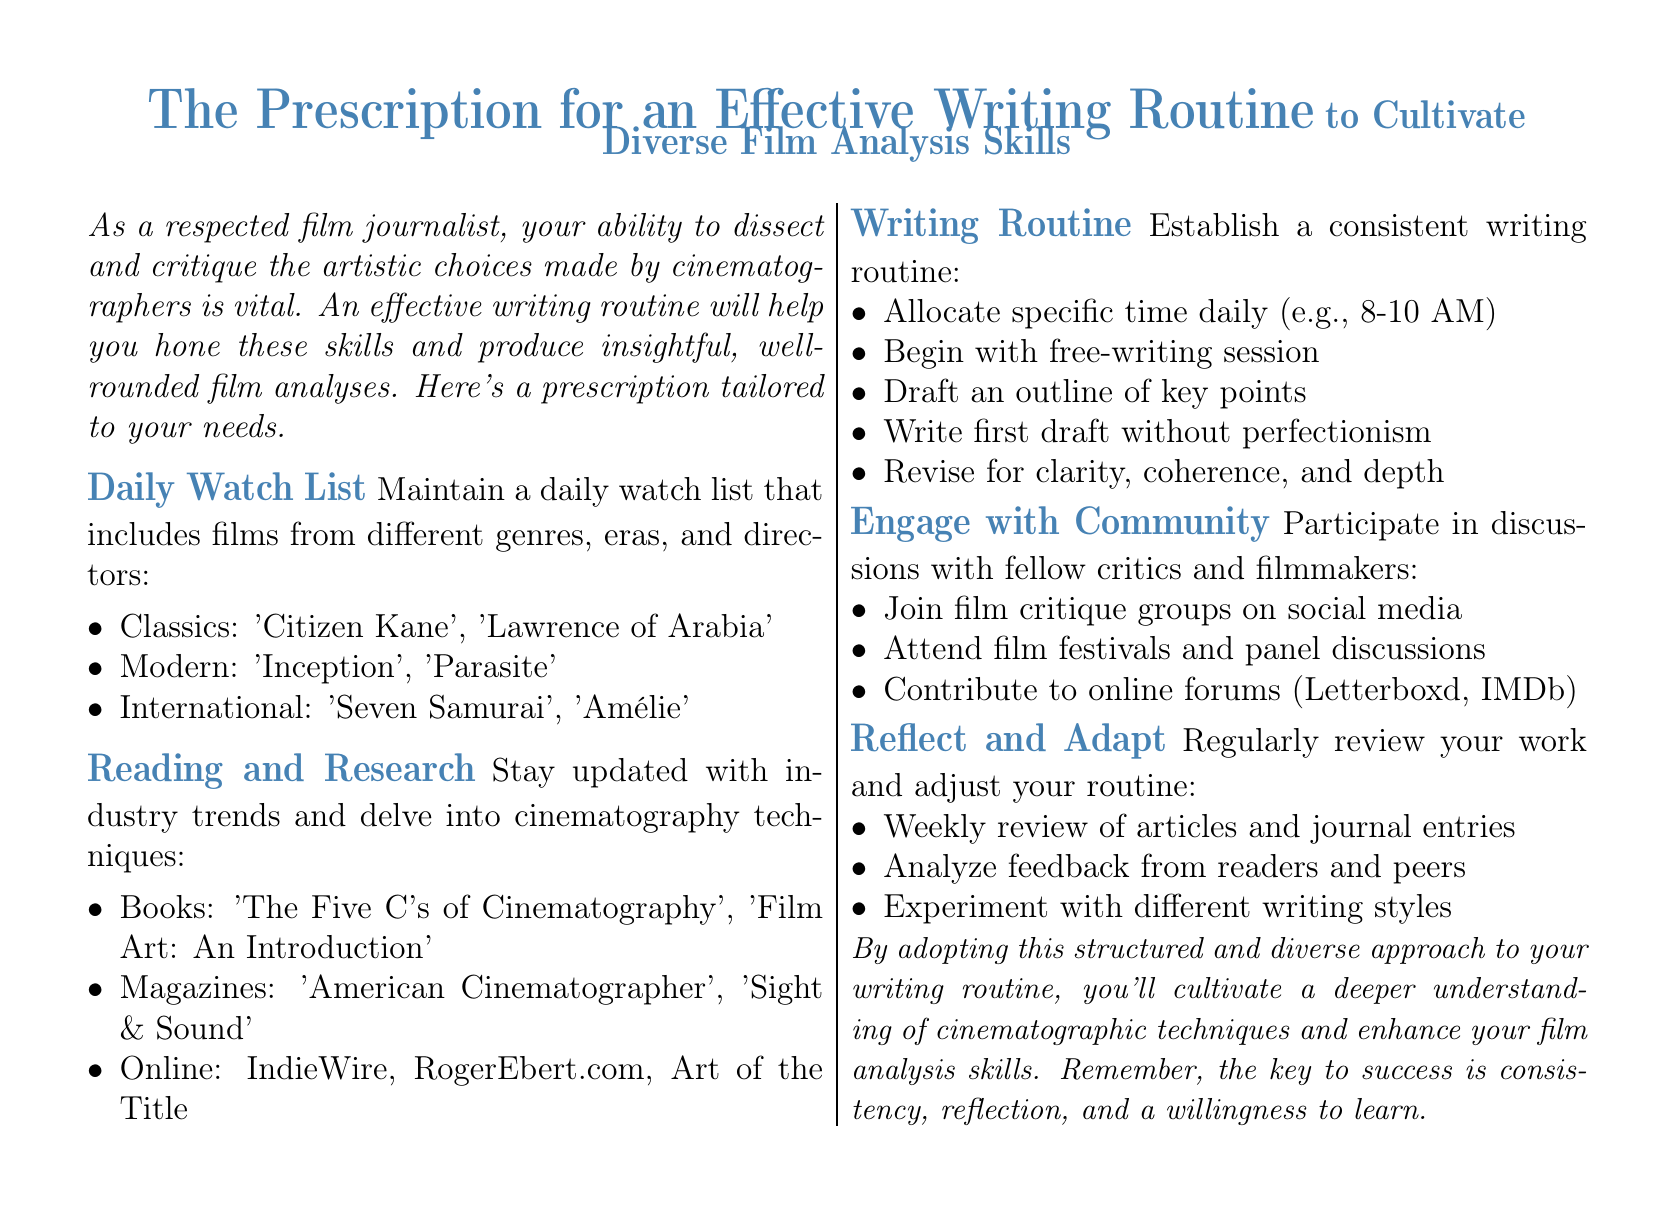what is included in the daily watch list? The daily watch list includes films from different genres, eras, and directors, such as classics, modern, and international films.
Answer: classics, modern, international name one book recommended for reading and research. The document lists books to stay updated with industry trends and delve into cinematography techniques; one example is provided.
Answer: The Five C's of Cinematography what is the suggested time to allocate for the writing routine? The document recommends a specific time to allocate for writing, which aids in establishing a consistent writing routine.
Answer: 8-10 AM what is one way to engage with the community? The document suggests various methods to engage with fellow critics and filmmakers, emphasizing participation in discussions.
Answer: Join film critique groups on social media how often should you review your work? The document recommends a frequency for reviewing your work as part of the reflection and adaptation process in the writing routine.
Answer: Weekly 